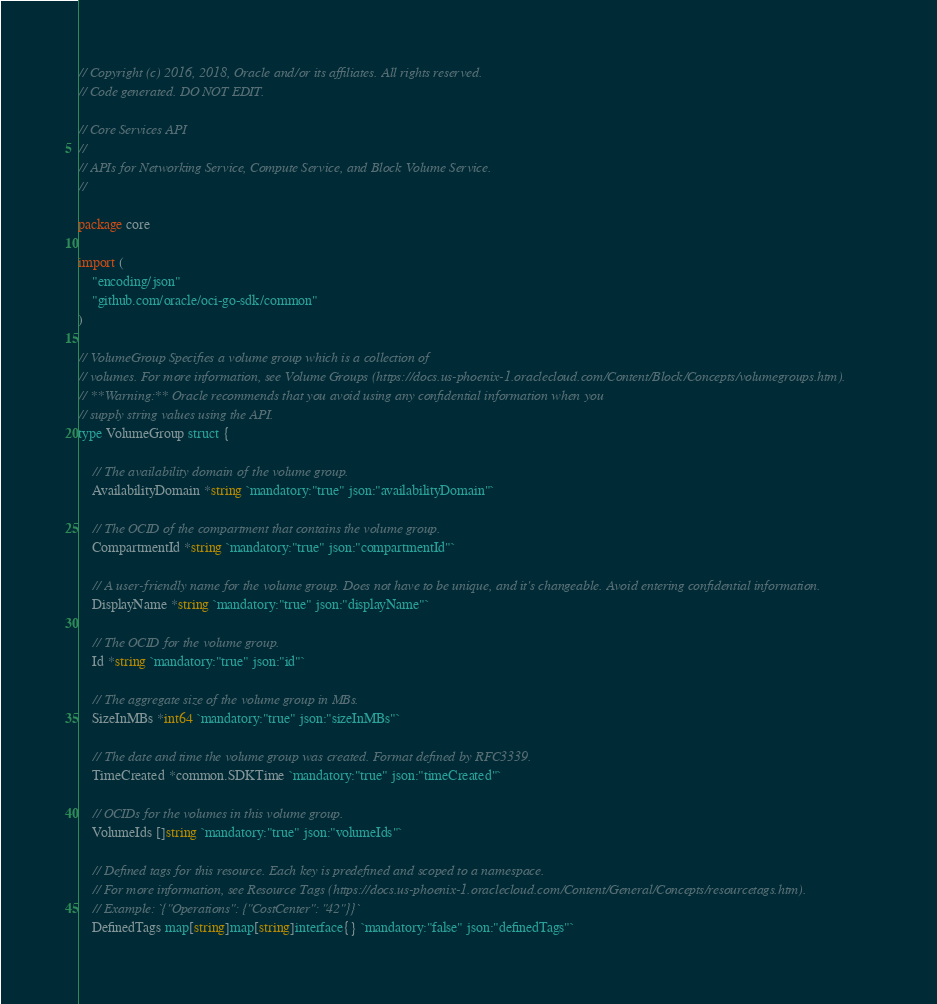<code> <loc_0><loc_0><loc_500><loc_500><_Go_>// Copyright (c) 2016, 2018, Oracle and/or its affiliates. All rights reserved.
// Code generated. DO NOT EDIT.

// Core Services API
//
// APIs for Networking Service, Compute Service, and Block Volume Service.
//

package core

import (
	"encoding/json"
	"github.com/oracle/oci-go-sdk/common"
)

// VolumeGroup Specifies a volume group which is a collection of
// volumes. For more information, see Volume Groups (https://docs.us-phoenix-1.oraclecloud.com/Content/Block/Concepts/volumegroups.htm).
// **Warning:** Oracle recommends that you avoid using any confidential information when you
// supply string values using the API.
type VolumeGroup struct {

	// The availability domain of the volume group.
	AvailabilityDomain *string `mandatory:"true" json:"availabilityDomain"`

	// The OCID of the compartment that contains the volume group.
	CompartmentId *string `mandatory:"true" json:"compartmentId"`

	// A user-friendly name for the volume group. Does not have to be unique, and it's changeable. Avoid entering confidential information.
	DisplayName *string `mandatory:"true" json:"displayName"`

	// The OCID for the volume group.
	Id *string `mandatory:"true" json:"id"`

	// The aggregate size of the volume group in MBs.
	SizeInMBs *int64 `mandatory:"true" json:"sizeInMBs"`

	// The date and time the volume group was created. Format defined by RFC3339.
	TimeCreated *common.SDKTime `mandatory:"true" json:"timeCreated"`

	// OCIDs for the volumes in this volume group.
	VolumeIds []string `mandatory:"true" json:"volumeIds"`

	// Defined tags for this resource. Each key is predefined and scoped to a namespace.
	// For more information, see Resource Tags (https://docs.us-phoenix-1.oraclecloud.com/Content/General/Concepts/resourcetags.htm).
	// Example: `{"Operations": {"CostCenter": "42"}}`
	DefinedTags map[string]map[string]interface{} `mandatory:"false" json:"definedTags"`
</code> 